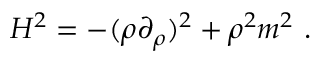<formula> <loc_0><loc_0><loc_500><loc_500>H ^ { 2 } = - ( \rho \partial _ { \rho } ) ^ { 2 } + \rho ^ { 2 } m ^ { 2 } .</formula> 